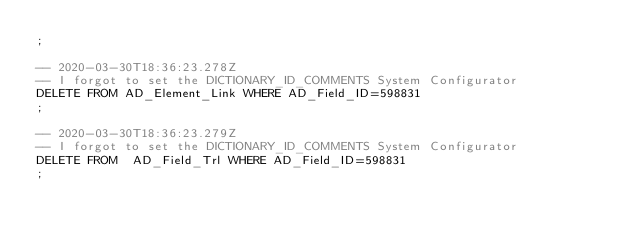<code> <loc_0><loc_0><loc_500><loc_500><_SQL_>;

-- 2020-03-30T18:36:23.278Z
-- I forgot to set the DICTIONARY_ID_COMMENTS System Configurator
DELETE FROM AD_Element_Link WHERE AD_Field_ID=598831
;

-- 2020-03-30T18:36:23.279Z
-- I forgot to set the DICTIONARY_ID_COMMENTS System Configurator
DELETE FROM  AD_Field_Trl WHERE AD_Field_ID=598831
;
</code> 